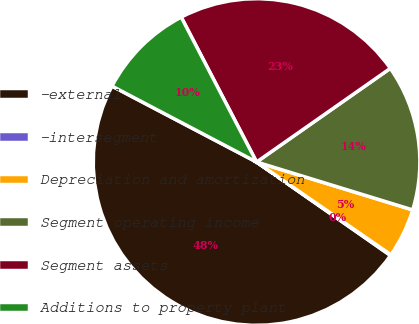Convert chart to OTSL. <chart><loc_0><loc_0><loc_500><loc_500><pie_chart><fcel>-external<fcel>-intersegment<fcel>Depreciation and amortization<fcel>Segment operating income<fcel>Segment assets<fcel>Additions to property plant<nl><fcel>48.0%<fcel>0.08%<fcel>4.88%<fcel>14.46%<fcel>22.91%<fcel>9.67%<nl></chart> 